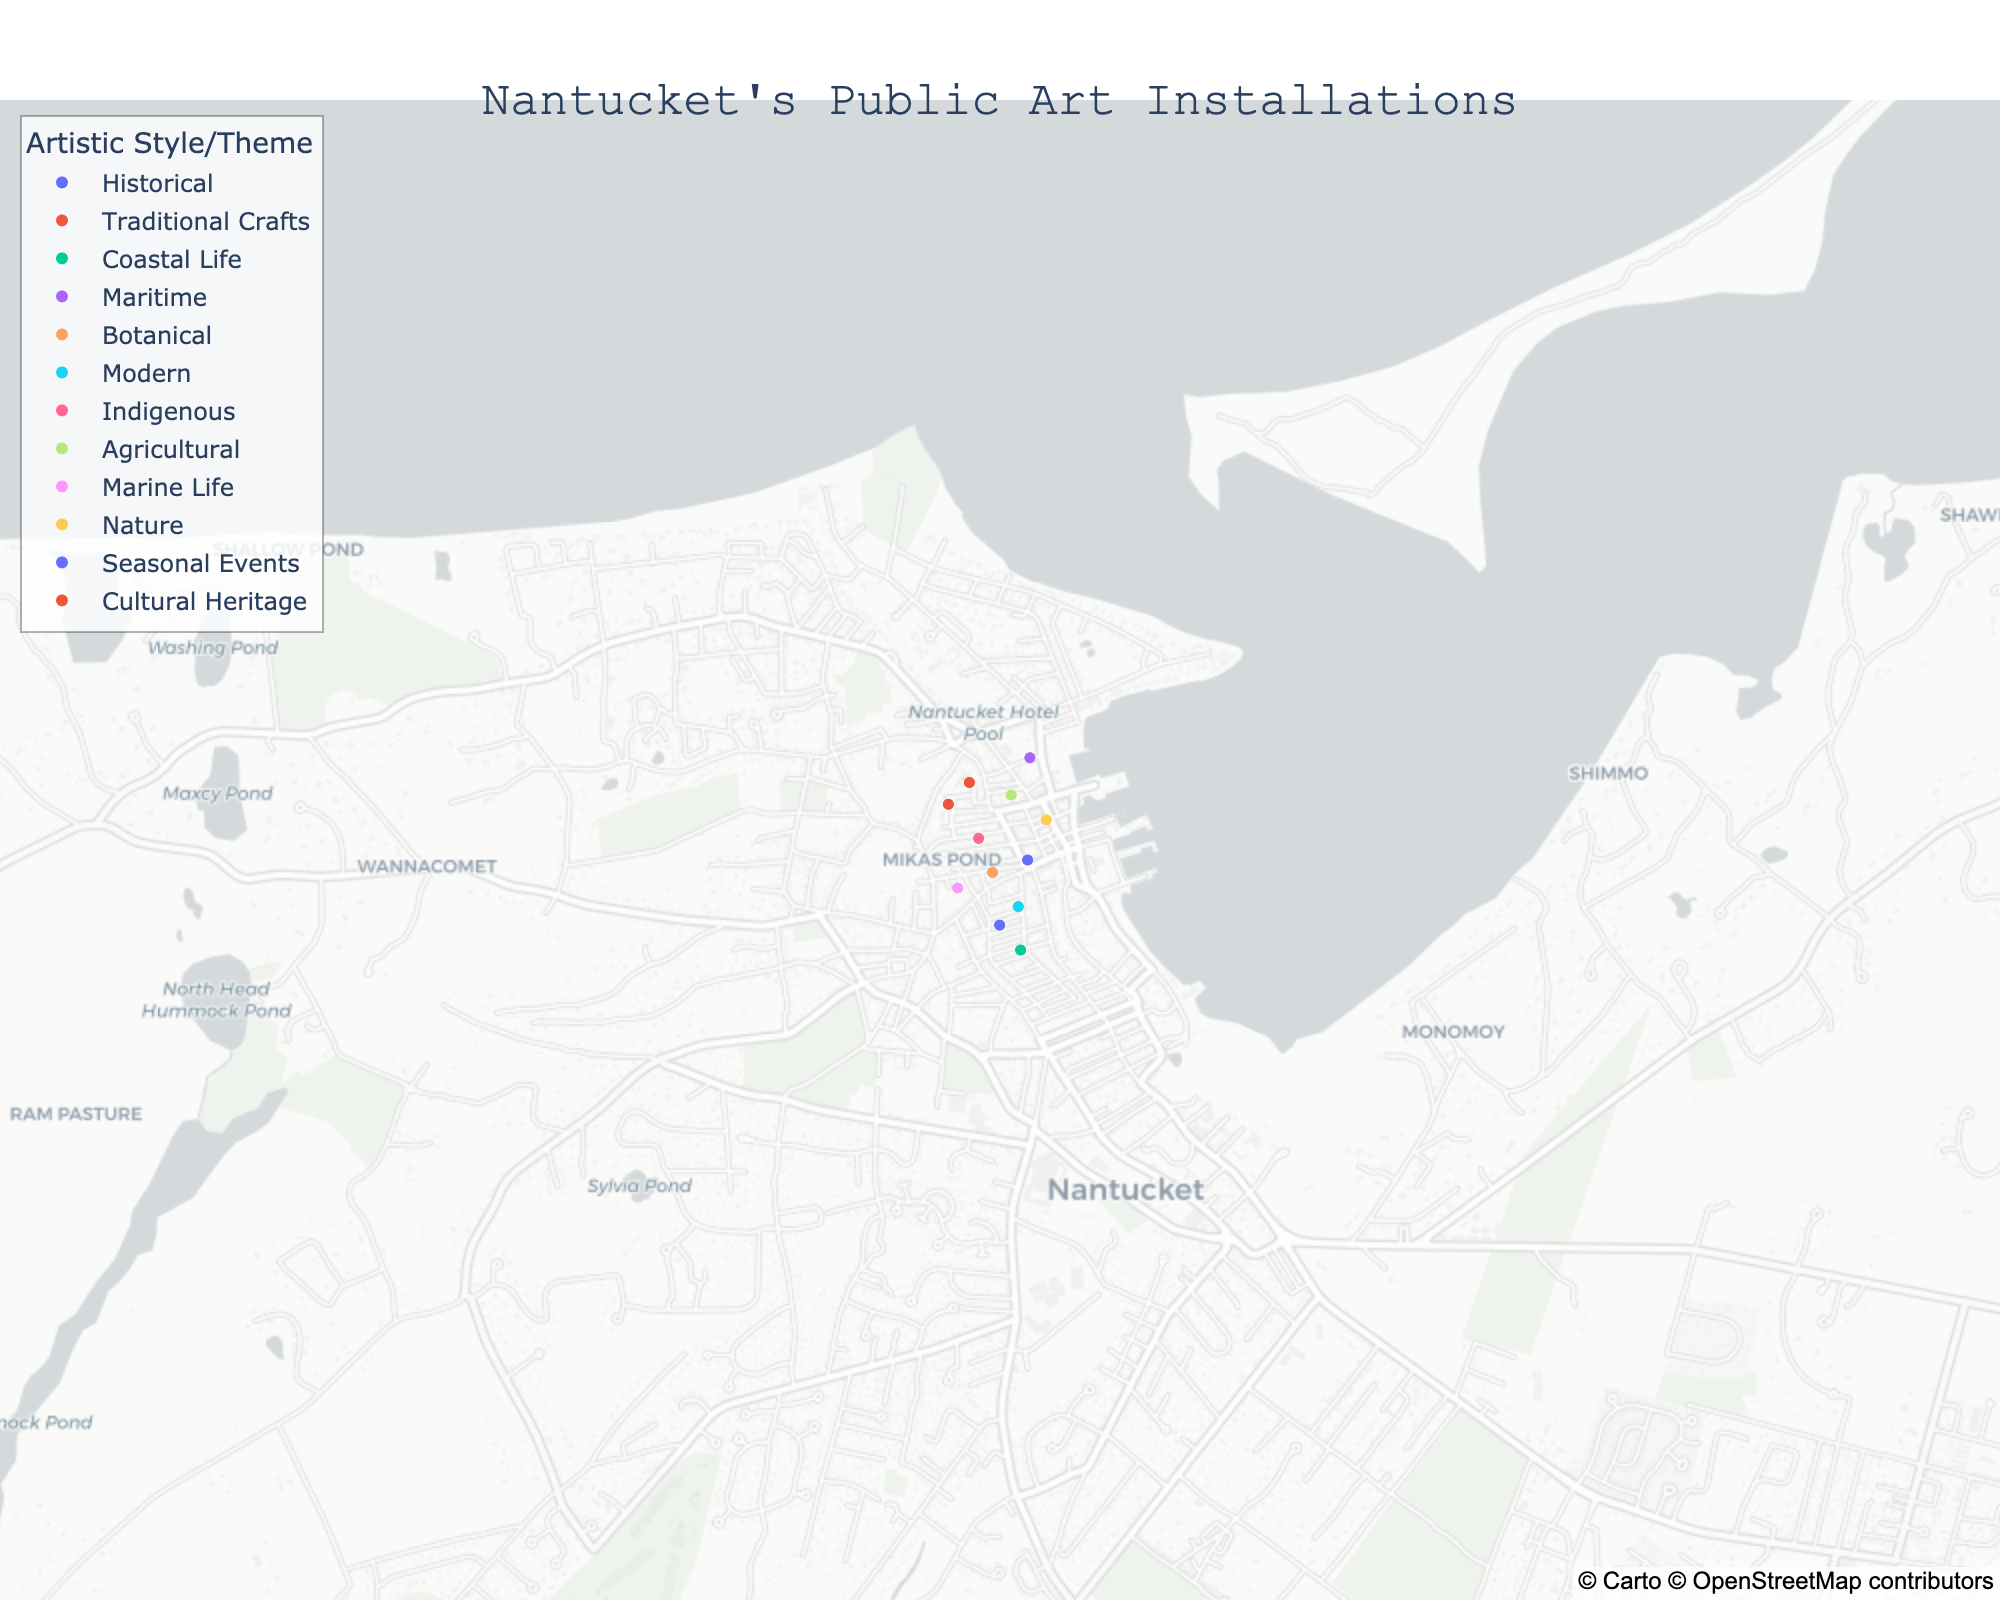What's the title of the plot? The title of the plot is usually located at the top center of the figure. Here, it should display information about what the figure represents. Look for the most prominent text at the top of the plot.
Answer: Nantucket's Public Art Installations How many public art installations are displayed on the map? Count the individual points marked on the map. Each point represents a single public art installation.
Answer: 12 Which art piece is located furthest to the west on the map? Identify the westernmost point by looking at the longitude values. The installation with the smallest longitude value will be the furthest west.
Answer: Seashell Mosaic Path Which artistic style or theme has the most number of installations? Observe the color-coded legend and count the number of points corresponding to each style/theme to determine which one appears most frequently.
Answer: There are no styles with more than one installation Which artist has installations labeled in the Coastal Life theme? Locate the installations categorized under the Coastal Life theme by their unique color and hover over the points to check the artist's name linked to this theme.
Answer: Maria Mitchell What is the average latitude of the installations in the east half of the map? First, identify the installations in the east half of the map (those with longitudes greater than the central longitude). Then calculate the mean latitude of these points. Central longitude is approximately -70.1002. Use installations with longitudes greater than this value.
Answer: Calculate coordinates step by step, then average them: Which public art installation related to traditional crafts is nearest to the center of the map? Look for the installation marked with traditional crafts in brown color. Calculate its distance to the center of the map by comparing the latitude and longitude differences from the center. Center longitude and latitude are the mean values (longitude: -70.1002, latitude: 41.28384).
Answer: Nantucket Lightship Basket Sculpture How many different artistic styles or themes are represented in the map? Count the number of distinct colors in the legend that represents different styles or themes.
Answer: 11 